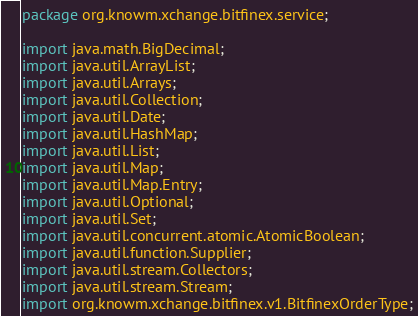<code> <loc_0><loc_0><loc_500><loc_500><_Java_>package org.knowm.xchange.bitfinex.service;

import java.math.BigDecimal;
import java.util.ArrayList;
import java.util.Arrays;
import java.util.Collection;
import java.util.Date;
import java.util.HashMap;
import java.util.List;
import java.util.Map;
import java.util.Map.Entry;
import java.util.Optional;
import java.util.Set;
import java.util.concurrent.atomic.AtomicBoolean;
import java.util.function.Supplier;
import java.util.stream.Collectors;
import java.util.stream.Stream;
import org.knowm.xchange.bitfinex.v1.BitfinexOrderType;</code> 